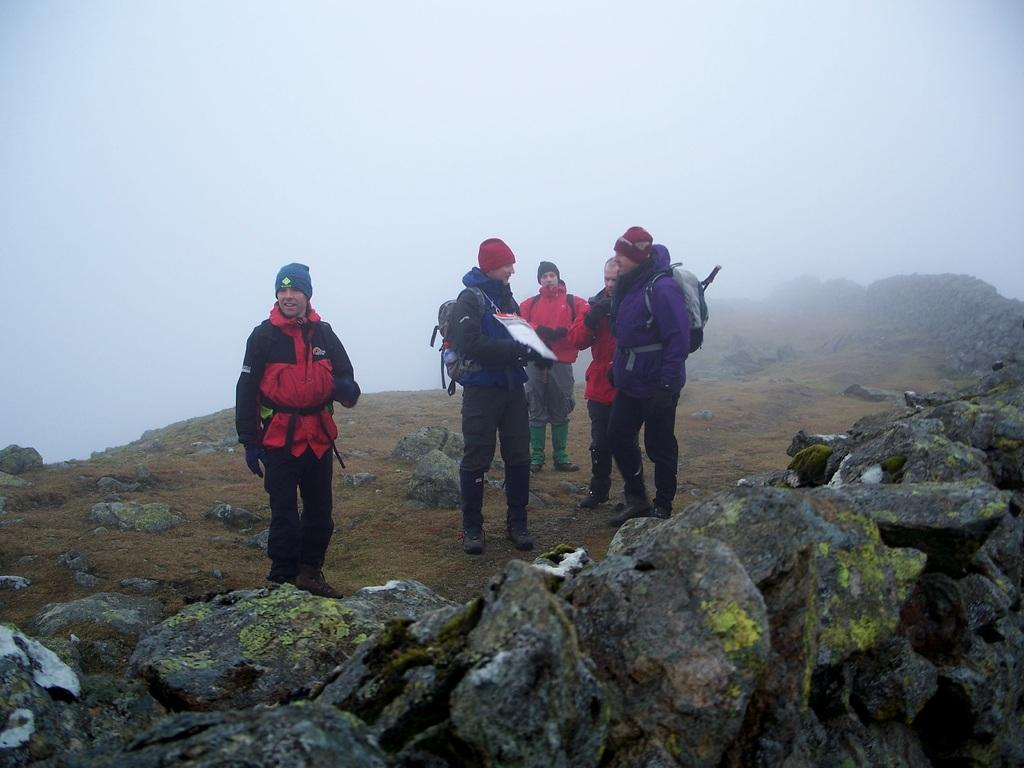What are the people in the image doing? The people in the image are standing. What are the people wearing on their backs? The people are wearing backpacks. Can you describe the object being held by one of the people? One person is holding an object, but the specifics are not clear from the image. What type of natural feature can be seen in the image? There are rocks visible in the image. What is visible in the background of the image? The sky is visible in the image. What type of umbrella is being used to shield the rocks from the sun in the image? There is no umbrella present in the image, and the rocks are not being shielded from the sun. Can you describe the type of skirt being worn by the person holding the object? There is no skirt visible in the image; the people are wearing backpacks. 